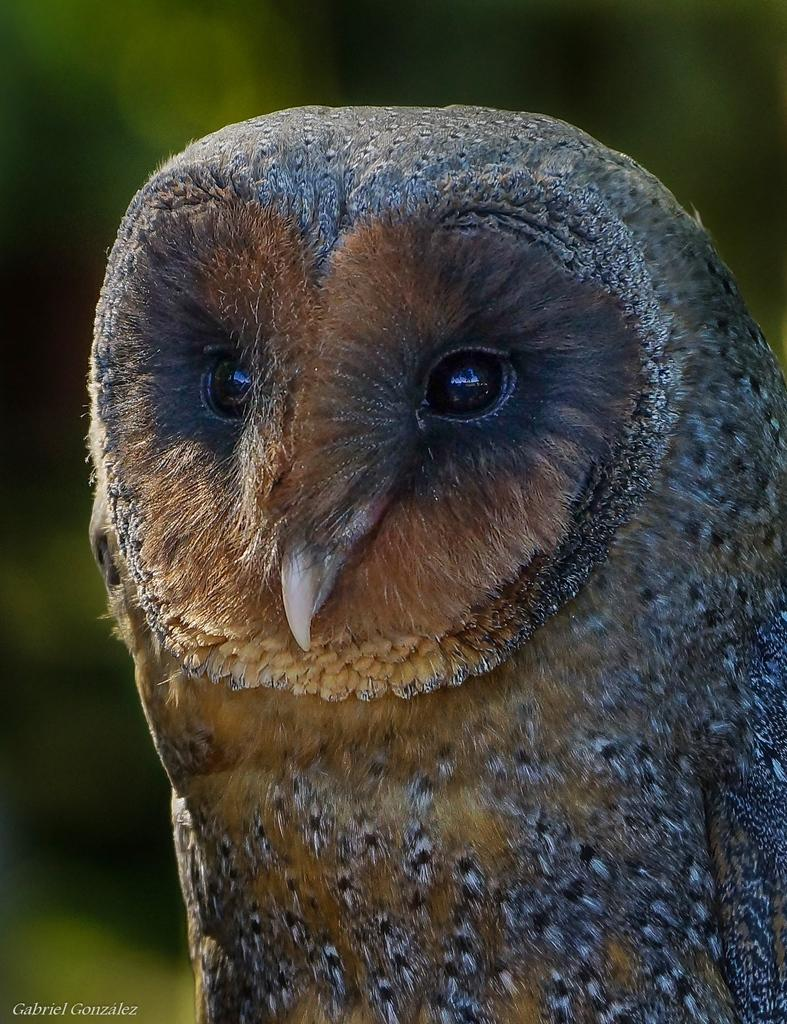What type of animal is in the image? There is an owl in the image. Can you describe the background of the image? The background of the image is blurred. What color is the blood on the owl's beak in the image? There is no blood present on the owl's beak in the image. 